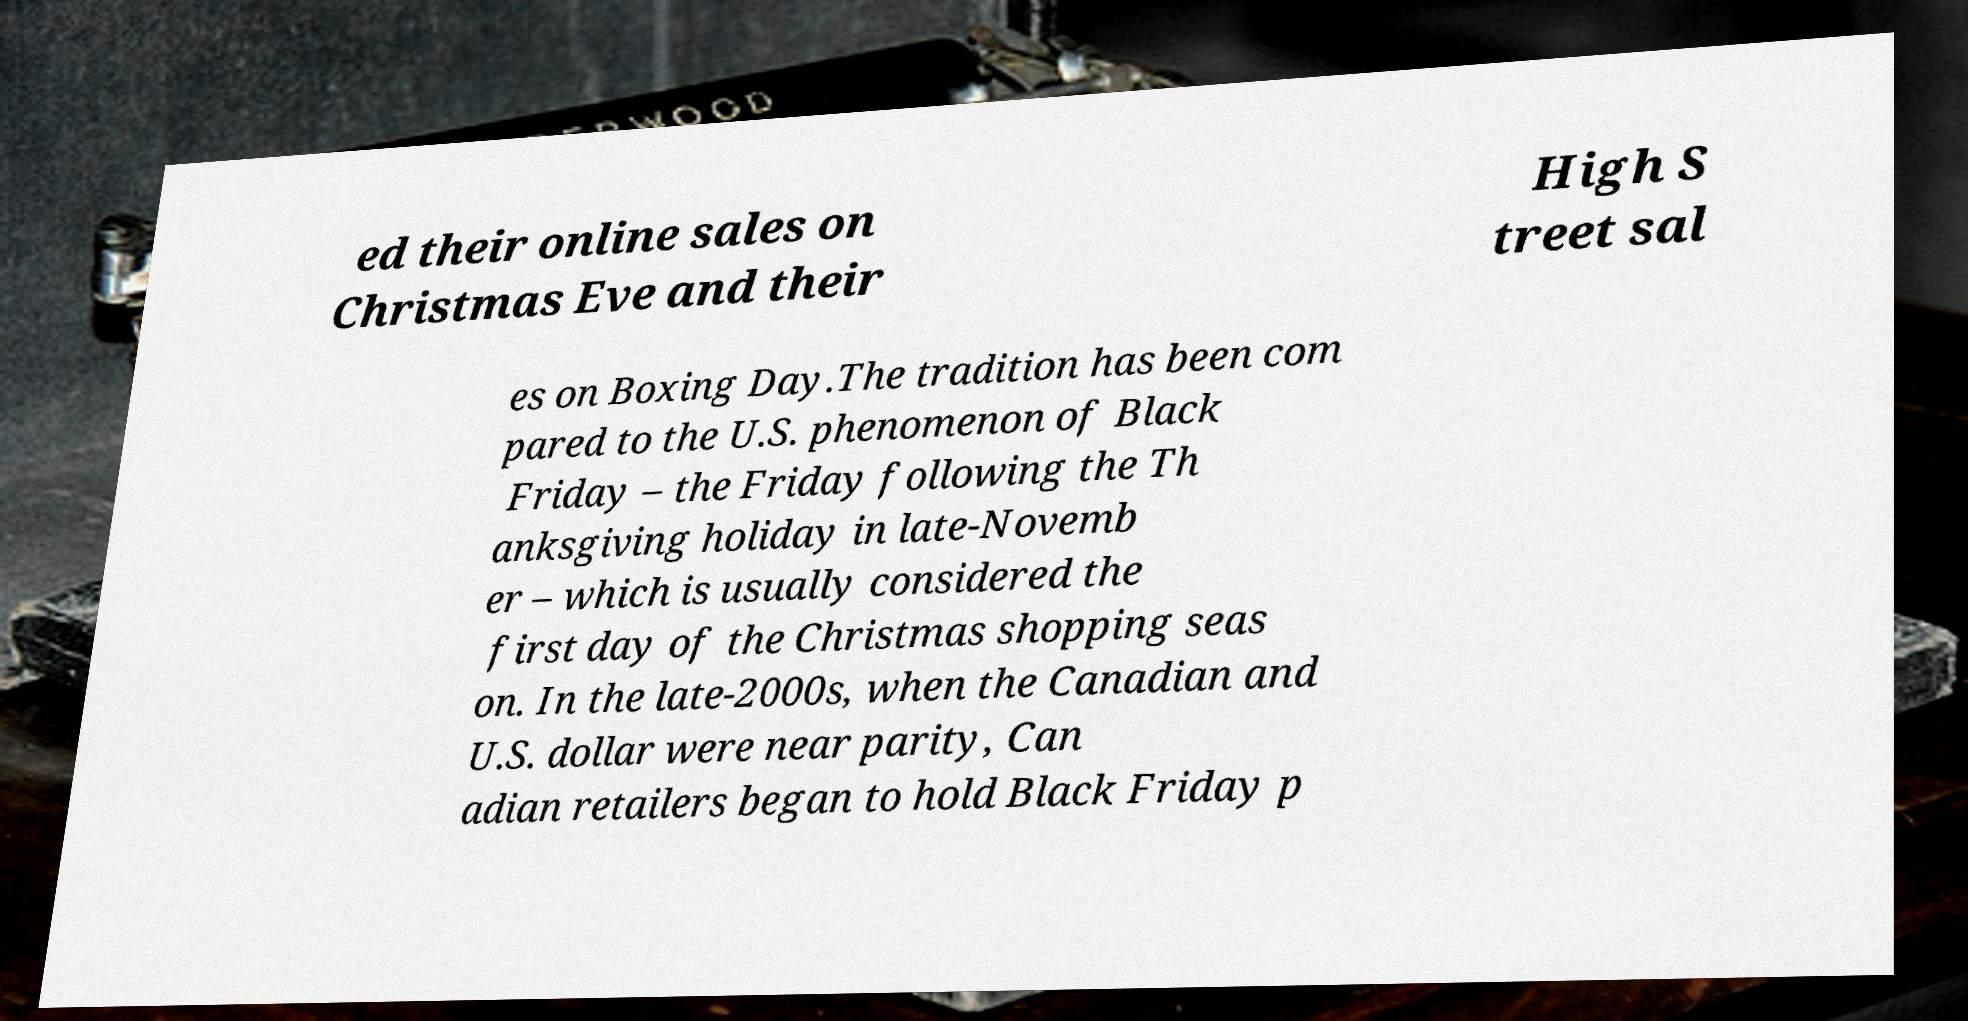Could you assist in decoding the text presented in this image and type it out clearly? ed their online sales on Christmas Eve and their High S treet sal es on Boxing Day.The tradition has been com pared to the U.S. phenomenon of Black Friday – the Friday following the Th anksgiving holiday in late-Novemb er – which is usually considered the first day of the Christmas shopping seas on. In the late-2000s, when the Canadian and U.S. dollar were near parity, Can adian retailers began to hold Black Friday p 